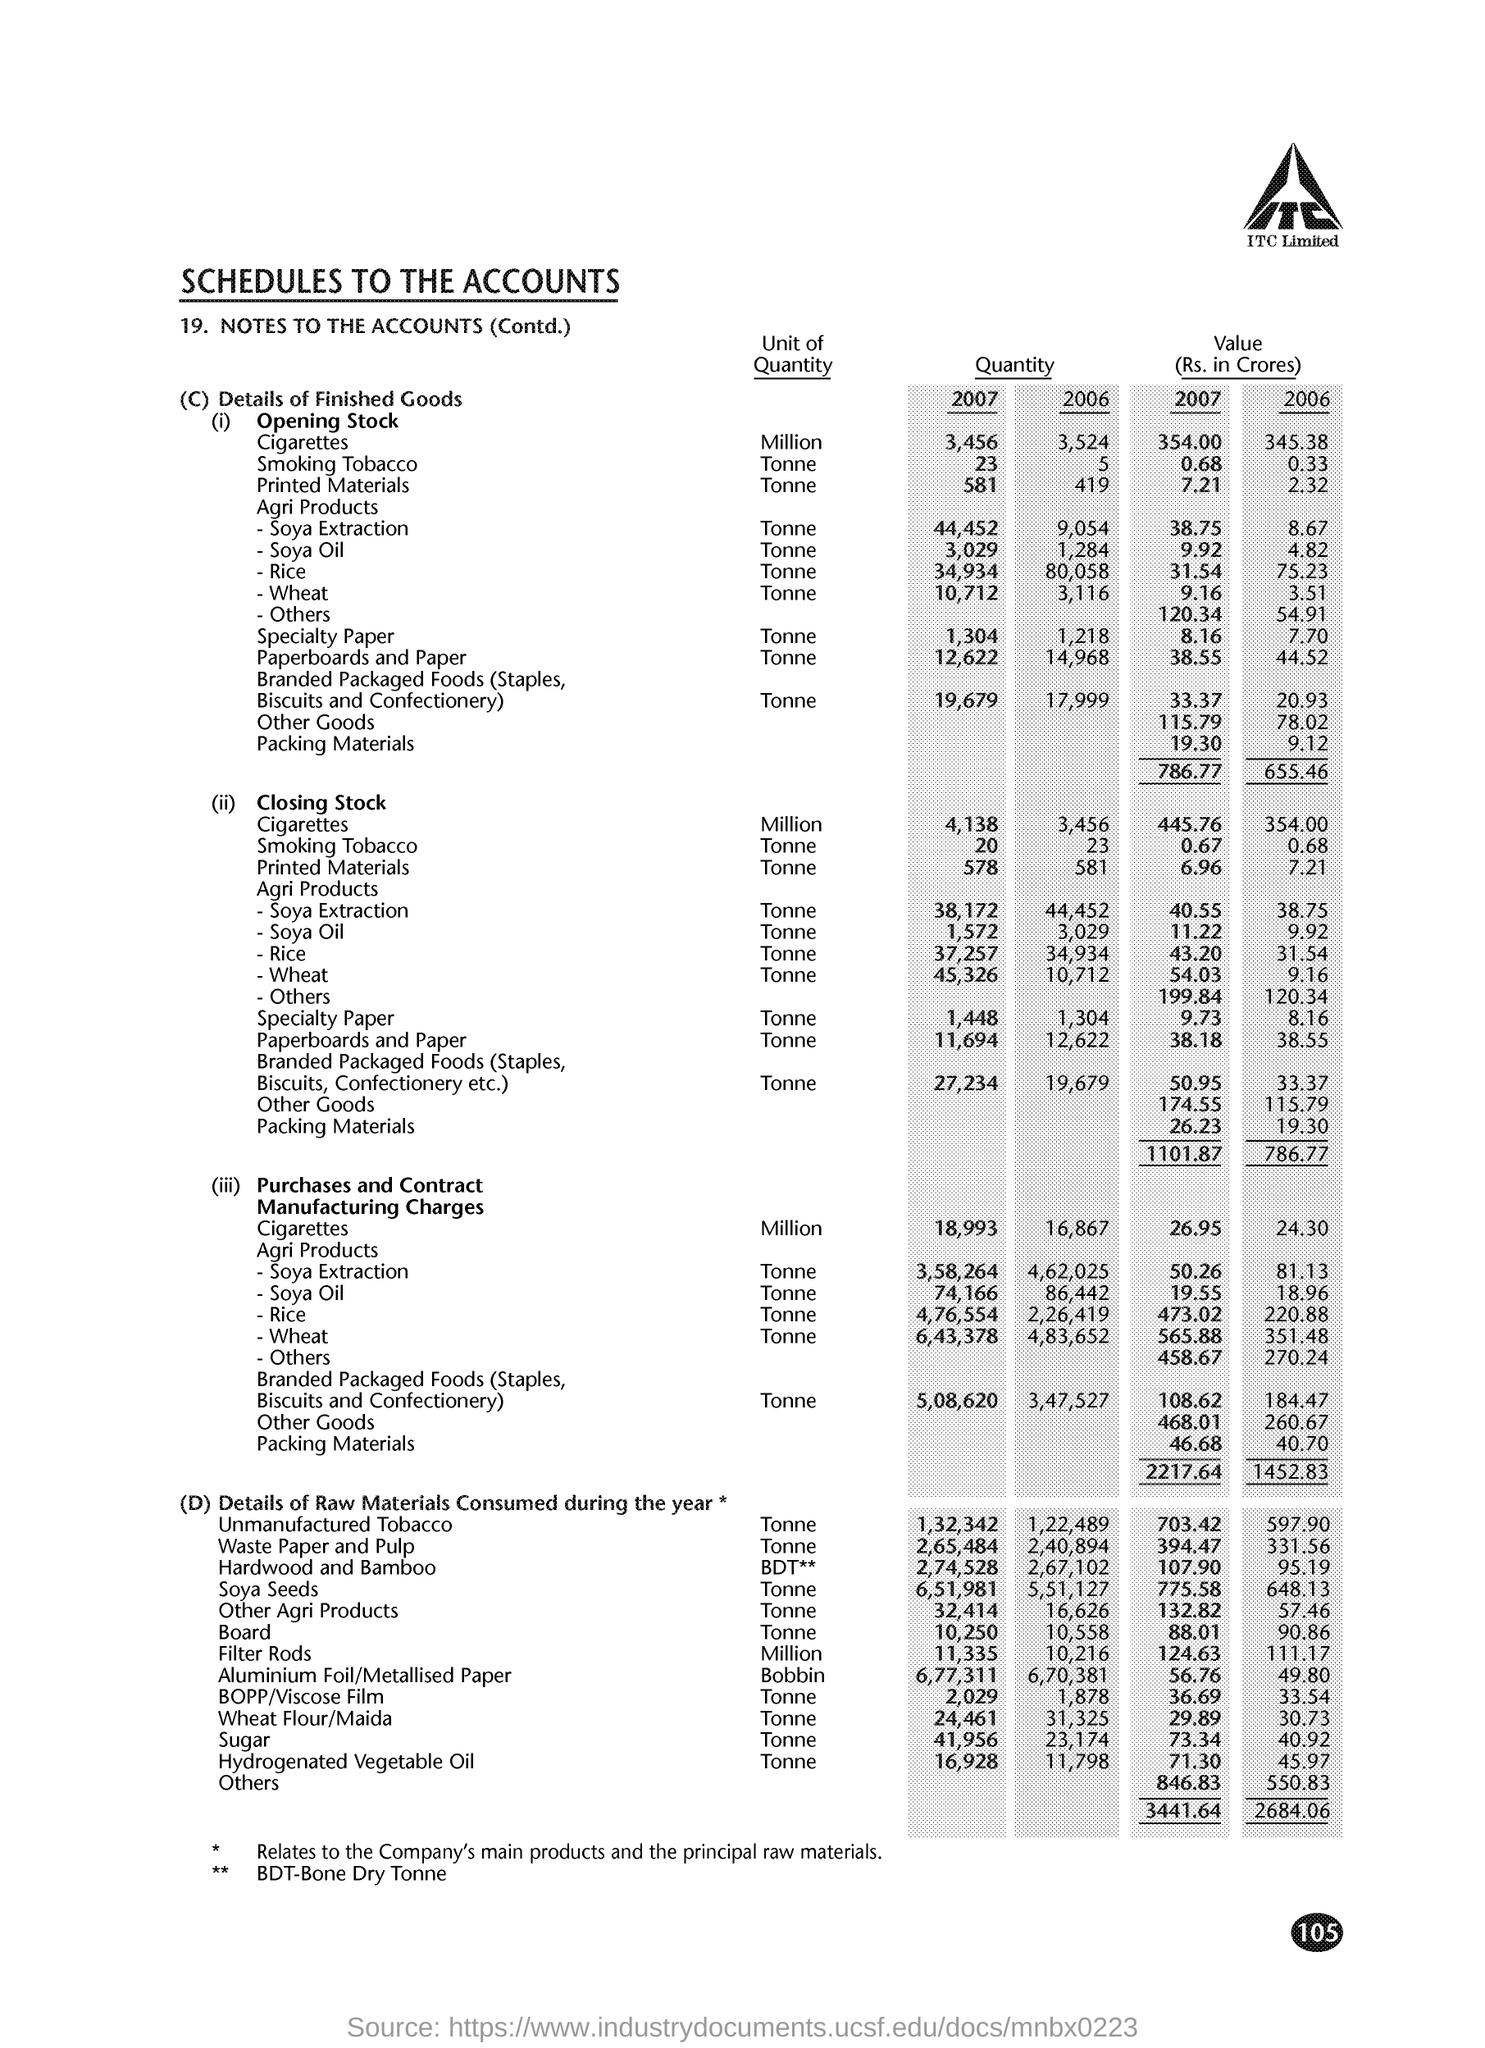Identify some key points in this picture. BDT stands for Bone Dry Tonne, which is a unit of measurement for dry bulk cargo. It refers to one metric tonne of cargo that is completely dry and free of moisture. The document is titled "Schedules to the Accounts. 